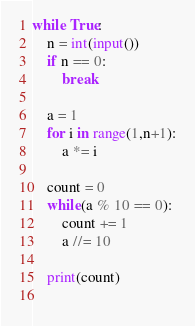<code> <loc_0><loc_0><loc_500><loc_500><_Python_>while True:
    n = int(input())
    if n == 0:
        break
    
    a = 1
    for i in range(1,n+1):
        a *= i
    
    count = 0
    while(a % 10 == 0):
        count += 1
        a //= 10
    
    print(count)
    
</code> 